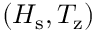<formula> <loc_0><loc_0><loc_500><loc_500>( H _ { s } , T _ { z } )</formula> 